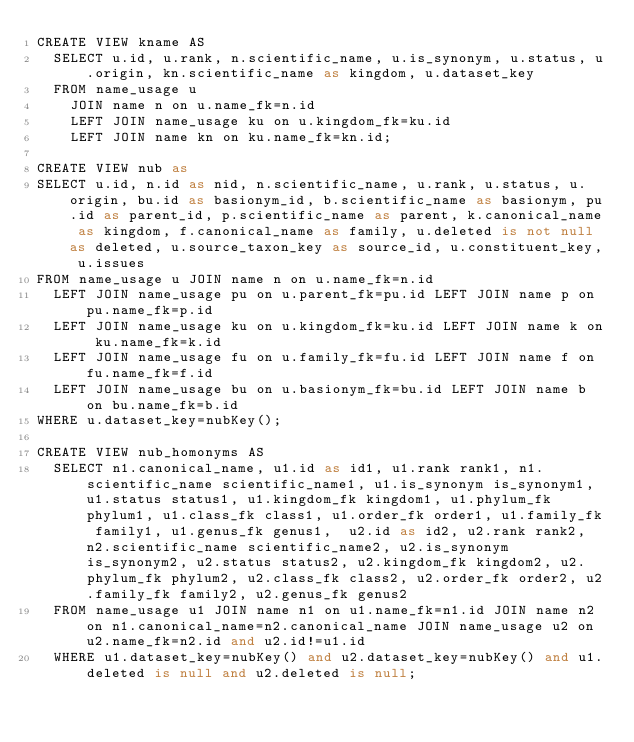Convert code to text. <code><loc_0><loc_0><loc_500><loc_500><_SQL_>CREATE VIEW kname AS
  SELECT u.id, u.rank, n.scientific_name, u.is_synonym, u.status, u.origin, kn.scientific_name as kingdom, u.dataset_key
  FROM name_usage u
    JOIN name n on u.name_fk=n.id
    LEFT JOIN name_usage ku on u.kingdom_fk=ku.id
    LEFT JOIN name kn on ku.name_fk=kn.id;

CREATE VIEW nub as
SELECT u.id, n.id as nid, n.scientific_name, u.rank, u.status, u.origin, bu.id as basionym_id, b.scientific_name as basionym, pu.id as parent_id, p.scientific_name as parent, k.canonical_name as kingdom, f.canonical_name as family, u.deleted is not null as deleted, u.source_taxon_key as source_id, u.constituent_key, u.issues
FROM name_usage u JOIN name n on u.name_fk=n.id
  LEFT JOIN name_usage pu on u.parent_fk=pu.id LEFT JOIN name p on pu.name_fk=p.id
  LEFT JOIN name_usage ku on u.kingdom_fk=ku.id LEFT JOIN name k on ku.name_fk=k.id
  LEFT JOIN name_usage fu on u.family_fk=fu.id LEFT JOIN name f on fu.name_fk=f.id
  LEFT JOIN name_usage bu on u.basionym_fk=bu.id LEFT JOIN name b on bu.name_fk=b.id
WHERE u.dataset_key=nubKey();

CREATE VIEW nub_homonyms AS
  SELECT n1.canonical_name, u1.id as id1, u1.rank rank1, n1.scientific_name scientific_name1, u1.is_synonym is_synonym1, u1.status status1, u1.kingdom_fk kingdom1, u1.phylum_fk phylum1, u1.class_fk class1, u1.order_fk order1, u1.family_fk family1, u1.genus_fk genus1,  u2.id as id2, u2.rank rank2, n2.scientific_name scientific_name2, u2.is_synonym is_synonym2, u2.status status2, u2.kingdom_fk kingdom2, u2.phylum_fk phylum2, u2.class_fk class2, u2.order_fk order2, u2.family_fk family2, u2.genus_fk genus2
  FROM name_usage u1 JOIN name n1 on u1.name_fk=n1.id JOIN name n2 on n1.canonical_name=n2.canonical_name JOIN name_usage u2 on u2.name_fk=n2.id and u2.id!=u1.id
  WHERE u1.dataset_key=nubKey() and u2.dataset_key=nubKey() and u1.deleted is null and u2.deleted is null;
</code> 